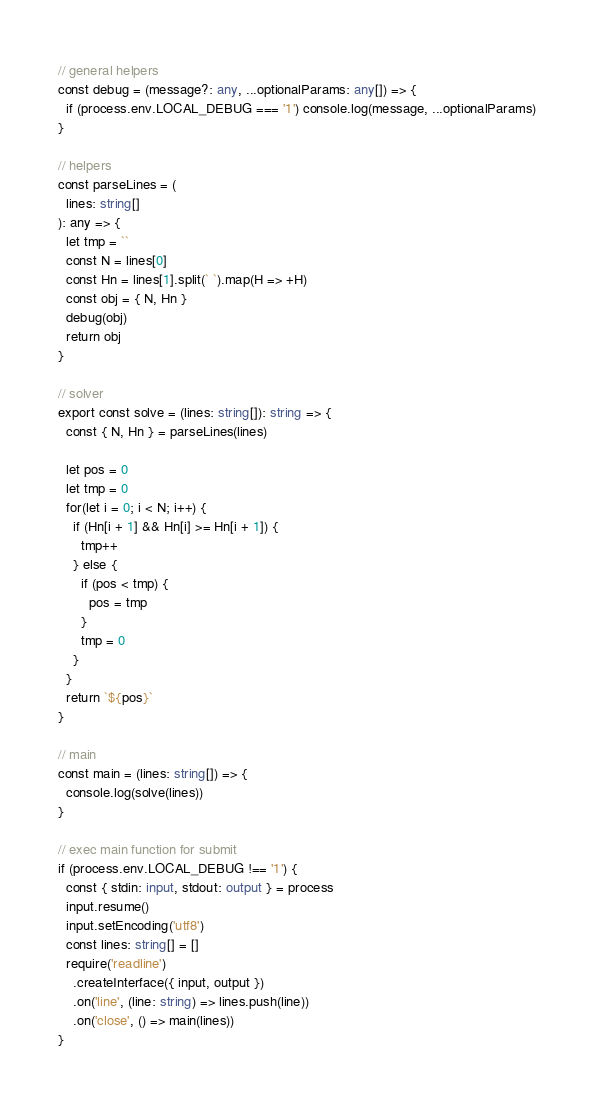<code> <loc_0><loc_0><loc_500><loc_500><_TypeScript_>// general helpers
const debug = (message?: any, ...optionalParams: any[]) => {
  if (process.env.LOCAL_DEBUG === '1') console.log(message, ...optionalParams)
}

// helpers
const parseLines = (
  lines: string[]
): any => {
  let tmp = ``
  const N = lines[0]
  const Hn = lines[1].split(` `).map(H => +H)
  const obj = { N, Hn }
  debug(obj)
  return obj
}

// solver
export const solve = (lines: string[]): string => {
  const { N, Hn } = parseLines(lines)

  let pos = 0
  let tmp = 0
  for(let i = 0; i < N; i++) {
    if (Hn[i + 1] && Hn[i] >= Hn[i + 1]) {
      tmp++
    } else {
      if (pos < tmp) {
        pos = tmp
      }
      tmp = 0
    }
  }
  return `${pos}`
}

// main
const main = (lines: string[]) => {
  console.log(solve(lines))
}

// exec main function for submit
if (process.env.LOCAL_DEBUG !== '1') {
  const { stdin: input, stdout: output } = process
  input.resume()
  input.setEncoding('utf8')
  const lines: string[] = []
  require('readline')
    .createInterface({ input, output })
    .on('line', (line: string) => lines.push(line))
    .on('close', () => main(lines))
}</code> 